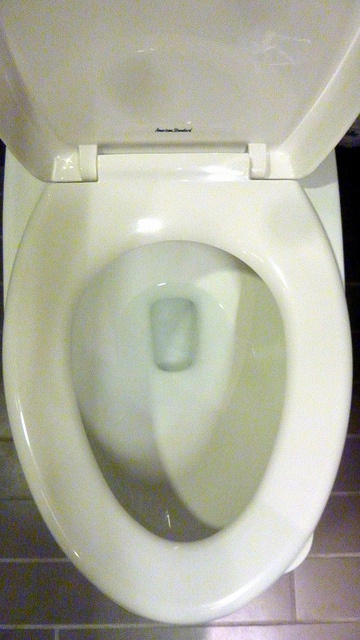Describe the objects in this image and their specific colors. I can see a toilet in darkgray, ivory, gray, beige, and tan tones in this image. 